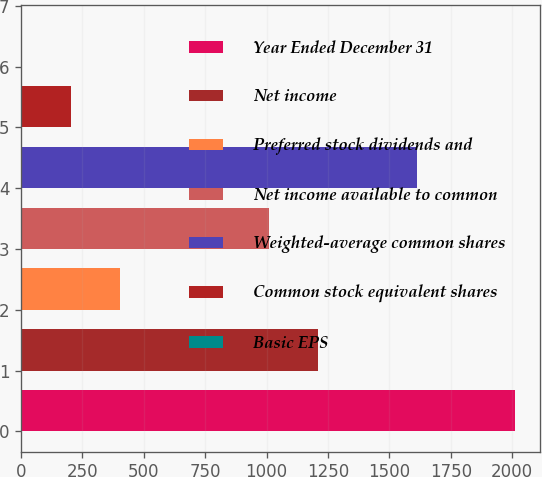Convert chart to OTSL. <chart><loc_0><loc_0><loc_500><loc_500><bar_chart><fcel>Year Ended December 31<fcel>Net income<fcel>Preferred stock dividends and<fcel>Net income available to common<fcel>Weighted-average common shares<fcel>Common stock equivalent shares<fcel>Basic EPS<nl><fcel>2013<fcel>1211.22<fcel>403.22<fcel>1010<fcel>1613.66<fcel>202<fcel>0.78<nl></chart> 